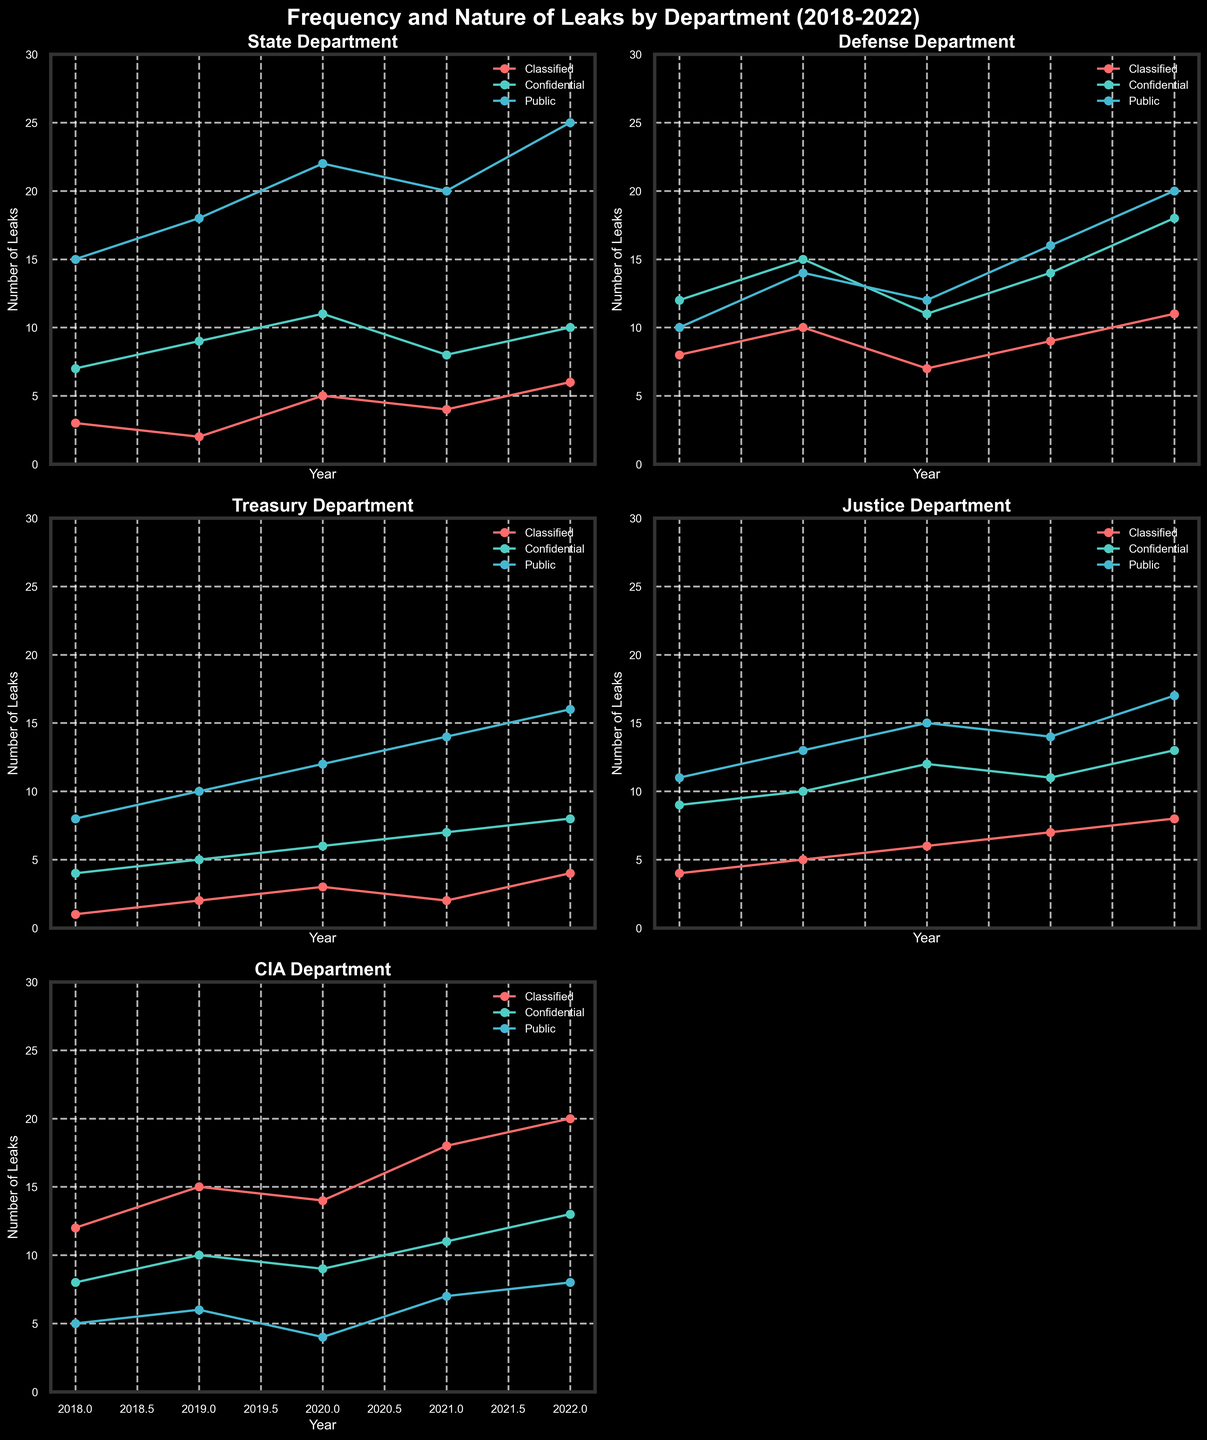What's the title of the figure? The title is prominently displayed at the top of the figure and reads: 'Frequency and Nature of Leaks by Department (2018-2022)'.
Answer: Frequency and Nature of Leaks by Department (2018-2022) How many departments are represented in the grid of subplots? Each subplot represents a different department, and we can count six subplots in the grid. One subplot is missing, so there are five departments represented.
Answer: Five departments What color represents 'Classified' leaks in the plots? In each subplot, 'Classified' leaks can be identified by their specific color. By examining any of the plots, we see that 'Classified' leaks are represented by a reddish color.
Answer: Reddish color In which year did the Justice Department have the highest number of 'Classified' leaks? By focusing on the specific subplot for the Justice Department, we can see the trend for 'Classified' leaks over the years. The peak occurs in 2022.
Answer: 2022 Which category of leaks had the highest number of occurrences for the Defense Department in 2022? Within the subplot for the Defense Department, we examine the lines for 2022. The 'Confidential' category, shown in a turquoise color, has the highest value.
Answer: Confidential Which department had more 'Classified' leaks in 2020, the State Department or the CIA? Comparing the 'Classified' leak lines for both the State Department and the CIA in their respective subplots for 2020, the CIA had more 'Classified' leaks.
Answer: CIA What is the total number of 'Public' leaks for the State Department over the five years? Summing the 'Public' leaks for the State Department in each of the years from 2018-2022: 15 + 18 + 22 + 20 + 25 = 100.
Answer: 100 Which department saw the largest increase in 'Confidential' leaks from 2018 to 2022? By examining the 'Confidential' leak trend lines for each department, calculate the difference between 2018 and 2022. The CIA saw an increase from 8 to 13, which is the largest increase.
Answer: CIA What is the average number of 'Confidential' leaks for the Treasury Department over the five years? Add the number of 'Confidential' leaks for the Treasury Department: 4 + 5 + 6 + 7 + 8, and then divide by 5: 30 / 5 = 6.
Answer: 6 Which department had the highest number of 'Classified' leaks overall from 2018-2022? By examining the total heights of the 'Classified' lines over all years for each department, it is evident that the CIA has the highest aggregate number of 'Classified' leaks.
Answer: CIA 